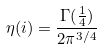<formula> <loc_0><loc_0><loc_500><loc_500>\eta ( i ) = \frac { \Gamma ( \frac { 1 } { 4 } ) } { 2 \pi ^ { 3 / 4 } }</formula> 